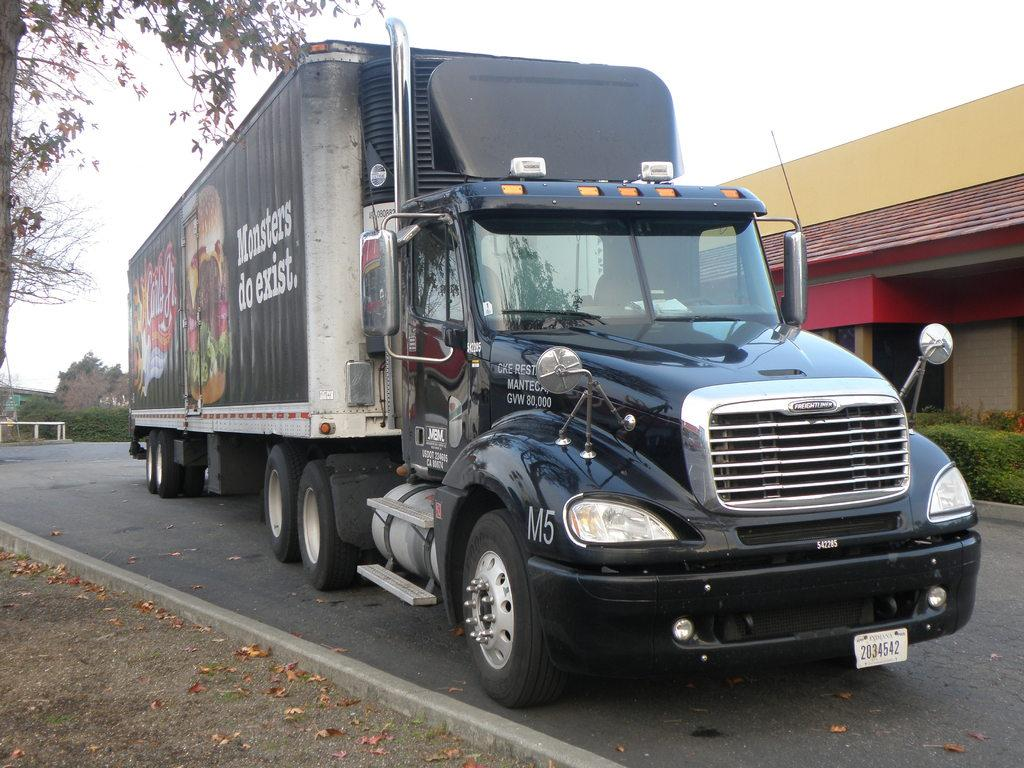What is on the road in the image? There is a vehicle on the road in the image. What else can be seen in the image besides the vehicle? There is a building, a tree, a hill, grass, dry leaves, and the sky visible in the image. Can you describe the vehicle in the image? The vehicle has headlights and a number plate. What type of terrain is visible in the image? The image shows a hill and grass, indicating a hilly or grassy terrain. What thought is the tree having in the image? Trees do not have thoughts, so this question cannot be answered. What type of pet can be seen sitting on the vehicle's hood in the image? There is no pet visible on the vehicle's hood in the image. 